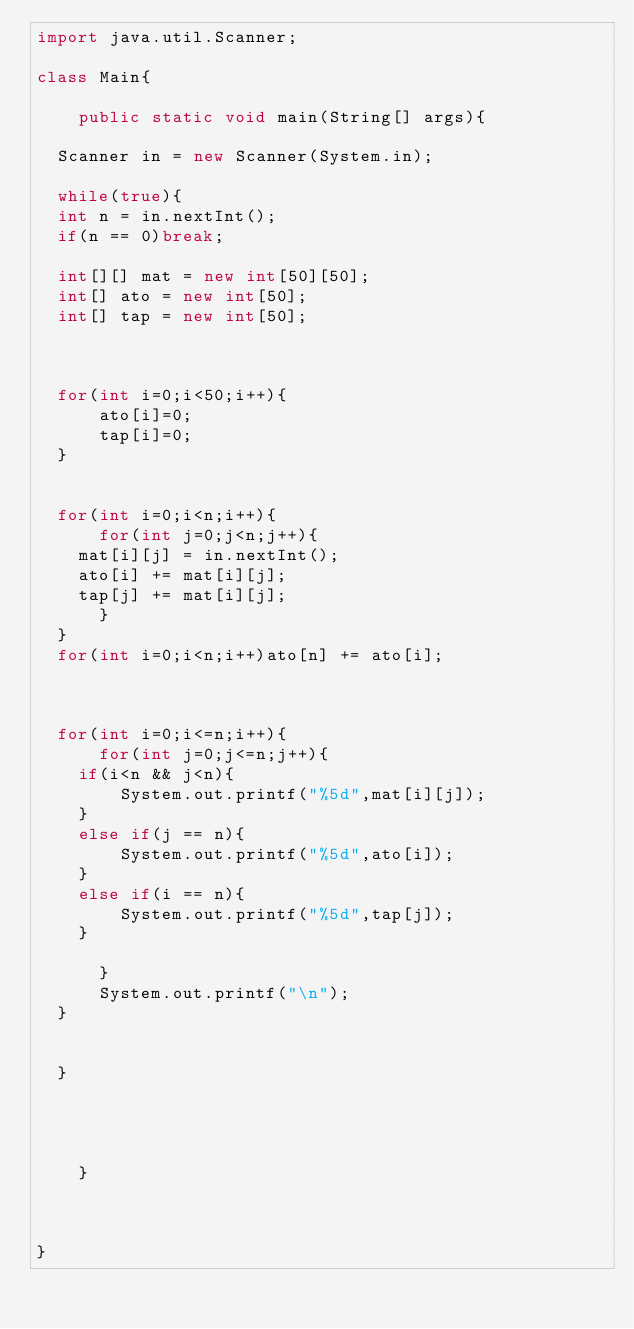Convert code to text. <code><loc_0><loc_0><loc_500><loc_500><_Java_>import java.util.Scanner;

class Main{

    public static void main(String[] args){

	Scanner in = new Scanner(System.in);

	while(true){
	int n = in.nextInt();
	if(n == 0)break;       

	int[][] mat = new int[50][50]; 
	int[] ato = new int[50];
	int[] tap = new int[50];

	

	for(int i=0;i<50;i++){
	    ato[i]=0;
	    tap[i]=0;
	}


	for(int i=0;i<n;i++){
	    for(int j=0;j<n;j++){
		mat[i][j] = in.nextInt();
		ato[i] += mat[i][j];
		tap[j] += mat[i][j];
	    }
	}
	for(int i=0;i<n;i++)ato[n] += ato[i];



	for(int i=0;i<=n;i++){
	    for(int j=0;j<=n;j++){
		if(i<n && j<n){
		    System.out.printf("%5d",mat[i][j]);
		}
		else if(j == n){
		    System.out.printf("%5d",ato[i]);
		}
		else if(i == n){
		    System.out.printf("%5d",tap[j]);
		}

	    }
	    System.out.printf("\n");
	}
	

	}




    }



}</code> 